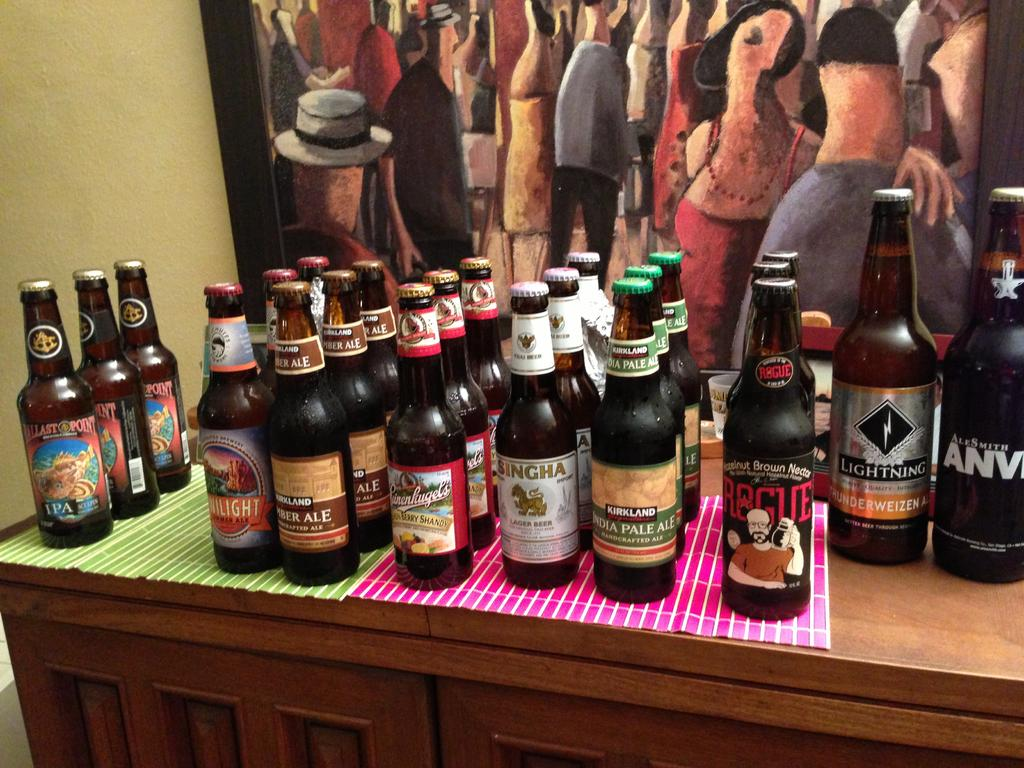What type of beverage containers are present in the image? There are beer bottles in the image. How are the beer bottles arranged on the table? The beer bottles are placed in rows on a table. What other item can be seen in the image besides the beer bottles? There is a painting visible in the image. What type of spot can be seen on the authority figure in the image? There is no authority figure or spot present in the image. What way does the painting depict the scene in the image? The provided facts do not mention any specific scene or context for the painting, so it is not possible to determine how the painting depicts the scene. 